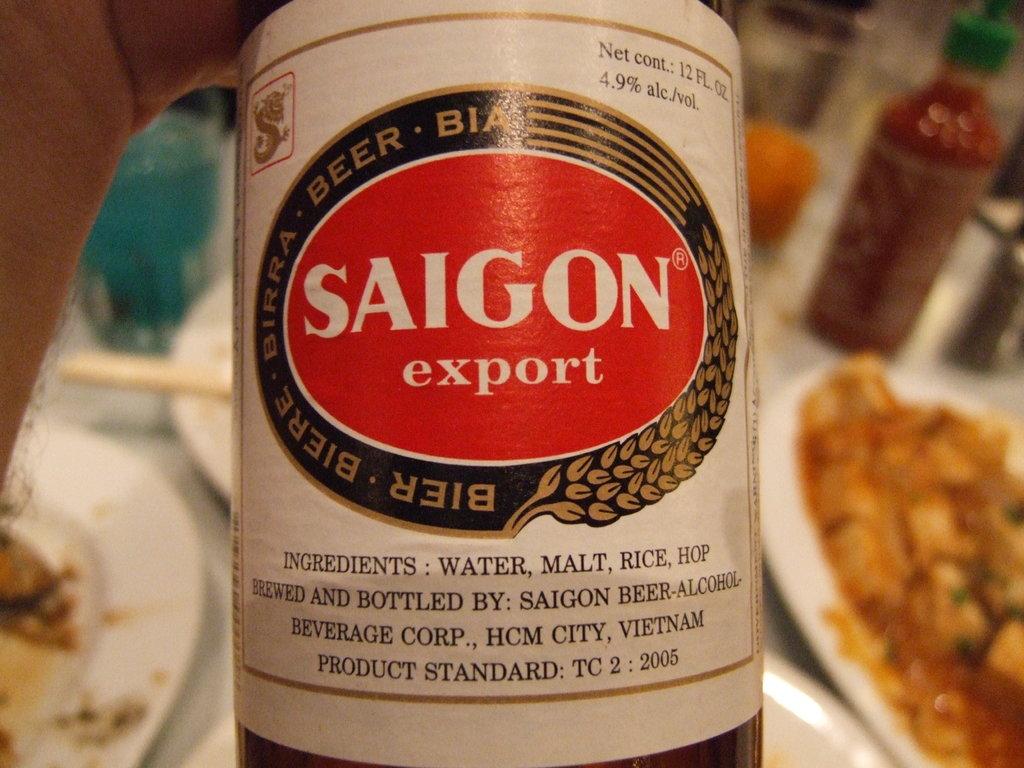What is the first ingredient listed?
Your answer should be very brief. Water. 